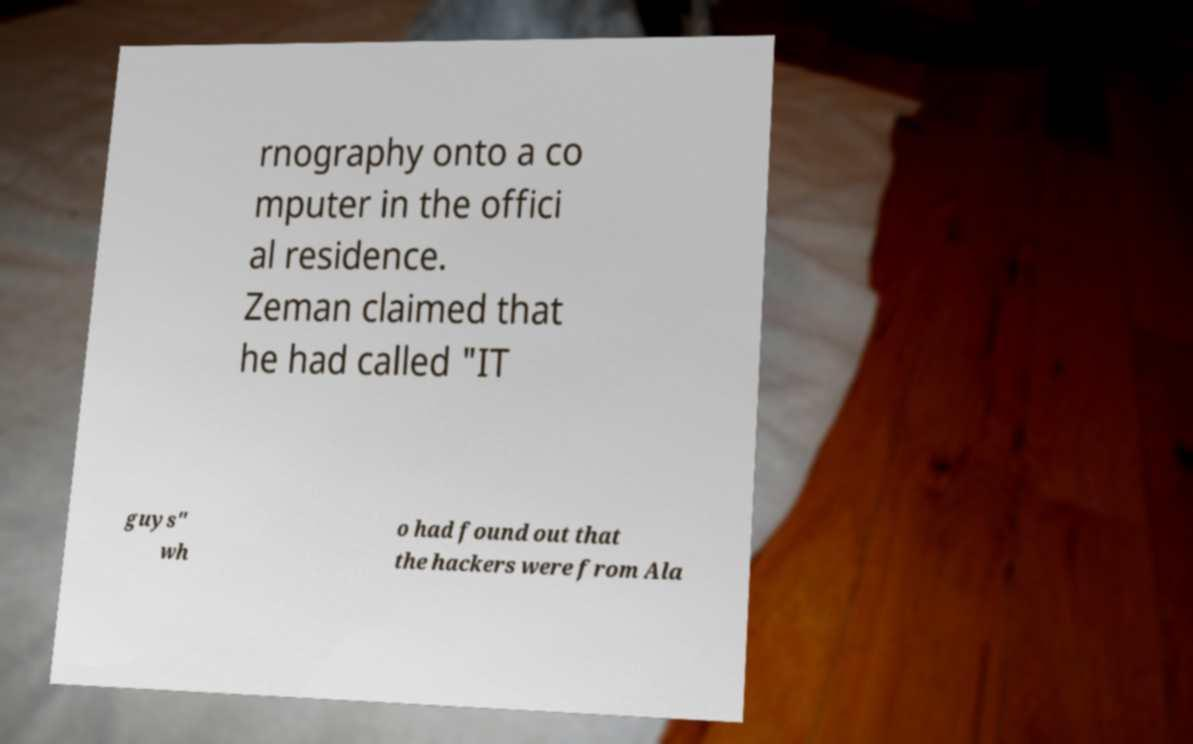Can you accurately transcribe the text from the provided image for me? rnography onto a co mputer in the offici al residence. Zeman claimed that he had called "IT guys" wh o had found out that the hackers were from Ala 